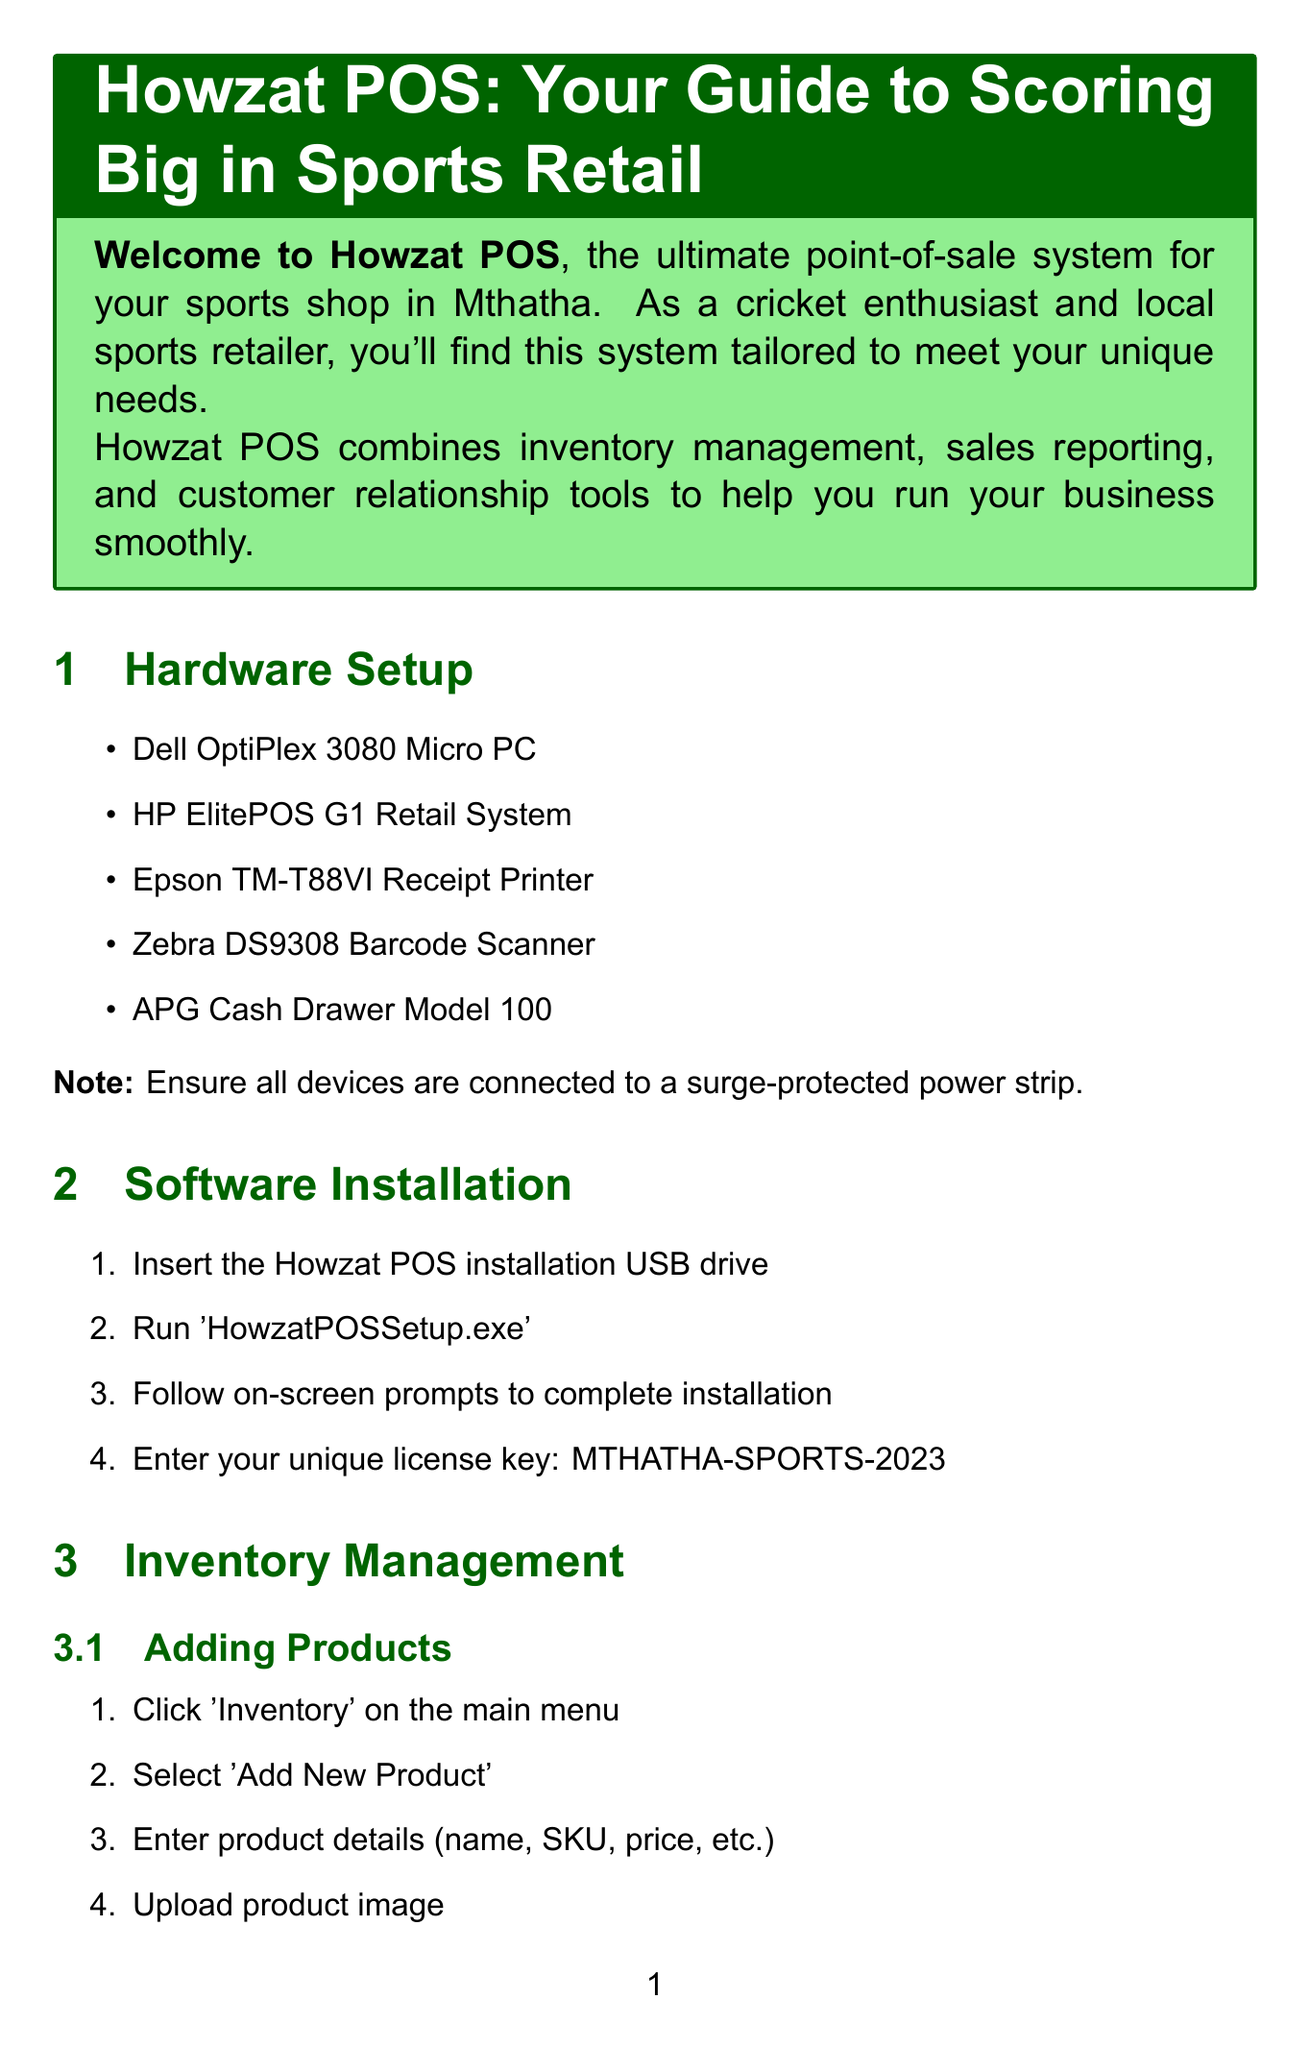What is the license key for installation? The license key for installation is provided in the software installation section of the document.
Answer: MTHATHA-SPORTS-2023 What hardware component is used for printing receipts? The hardware component associated with receipt printing is listed in the hardware setup section.
Answer: Epson TM-T88VI Receipt Printer How many points does a customer accumulate per R10 spent in the loyalty program? The loyalty program details include points accumulation information in the customer management section.
Answer: 1 point What is the maximum time allowed for returns and exchanges? The returns and exchanges policy specifies the maximum timeframe in the sales process section.
Answer: 14 days What are the three types of sales reporting metrics mentioned? The daily reports section outlines the key metrics generated daily.
Answer: Total sales, Number of transactions, Average transaction value How can one generate a report to track cricket equipment sales? The custom reports section describes how to create reports based on specific needs.
Answer: Use the Custom Report Builder What is the brand of the barcode scanner mentioned? The document lists the components necessary for the hardware setup, including the barcode scanner brand.
Answer: Zebra What should you check if the barcode scanner is not working? Troubleshooting advice in the document provides a solution for this common issue.
Answer: USB connection What is the contact email for support? The support contact section provides the email address for assistance.
Answer: support@howzatpos.co.za 